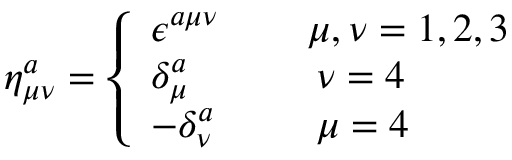<formula> <loc_0><loc_0><loc_500><loc_500>\eta _ { \mu \nu } ^ { a } = \left \{ \begin{array} { l l l } { { \epsilon ^ { a \mu \nu } \, } } & { \mu , \nu = 1 , 2 , 3 } \\ { { \delta _ { \mu } ^ { a } \, } } & { \, \nu = 4 \, } \\ { { - \delta _ { \nu } ^ { a } \, } } & { \, \mu = 4 \, } \end{array}</formula> 